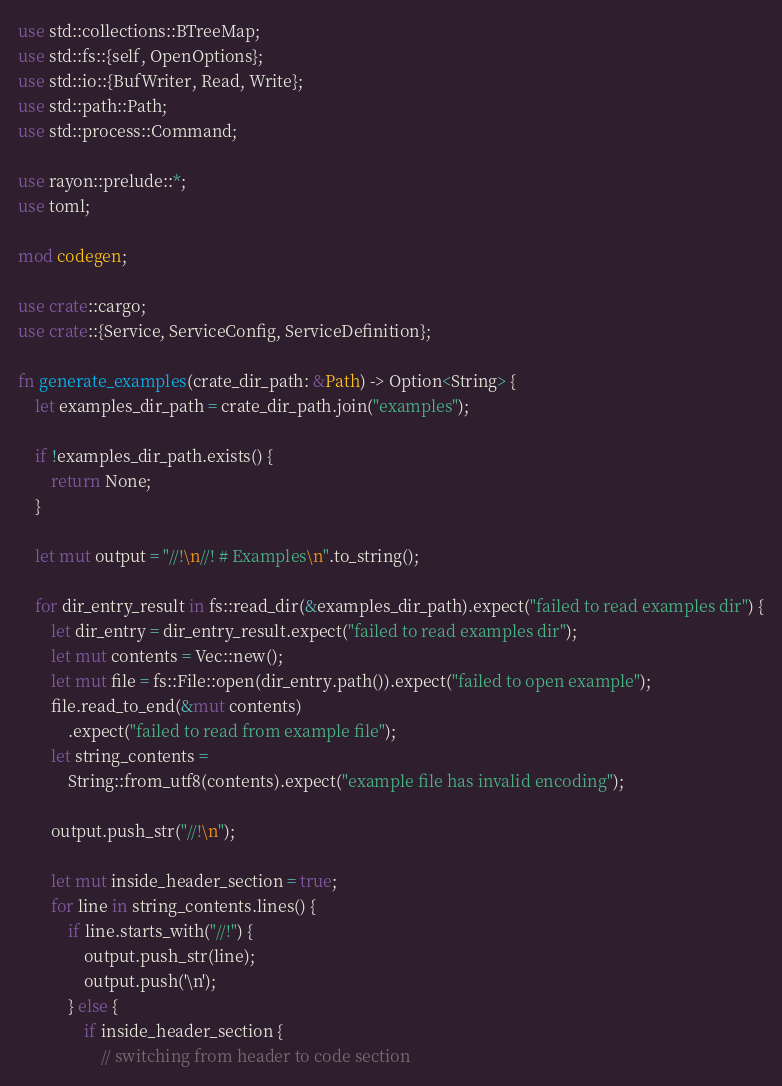<code> <loc_0><loc_0><loc_500><loc_500><_Rust_>use std::collections::BTreeMap;
use std::fs::{self, OpenOptions};
use std::io::{BufWriter, Read, Write};
use std::path::Path;
use std::process::Command;

use rayon::prelude::*;
use toml;

mod codegen;

use crate::cargo;
use crate::{Service, ServiceConfig, ServiceDefinition};

fn generate_examples(crate_dir_path: &Path) -> Option<String> {
    let examples_dir_path = crate_dir_path.join("examples");

    if !examples_dir_path.exists() {
        return None;
    }

    let mut output = "//!\n//! # Examples\n".to_string();

    for dir_entry_result in fs::read_dir(&examples_dir_path).expect("failed to read examples dir") {
        let dir_entry = dir_entry_result.expect("failed to read examples dir");
        let mut contents = Vec::new();
        let mut file = fs::File::open(dir_entry.path()).expect("failed to open example");
        file.read_to_end(&mut contents)
            .expect("failed to read from example file");
        let string_contents =
            String::from_utf8(contents).expect("example file has invalid encoding");

        output.push_str("//!\n");

        let mut inside_header_section = true;
        for line in string_contents.lines() {
            if line.starts_with("//!") {
                output.push_str(line);
                output.push('\n');
            } else {
                if inside_header_section {
                    // switching from header to code section</code> 